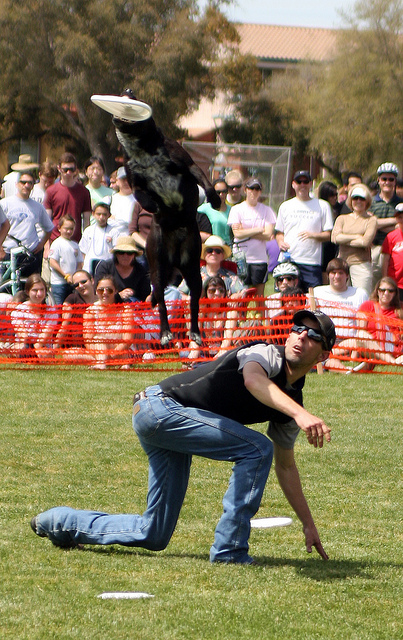<image>What is in the dog's mouth? I am not sure what is in the dog's mouth. It could be a frisbee. What is in the dog's mouth? I don't know what is in the dog's mouth. It looks like a frisbee.
### VQA
Q: What is the name of the building?
A: ['unknown', 'unknown', 'unknown', 'unknown', 'unknown', 'unknown', 'unknown', 'unknown', 'unknown', 'unknown']
### Answer
I don't know the name of the building. It is unknown. 